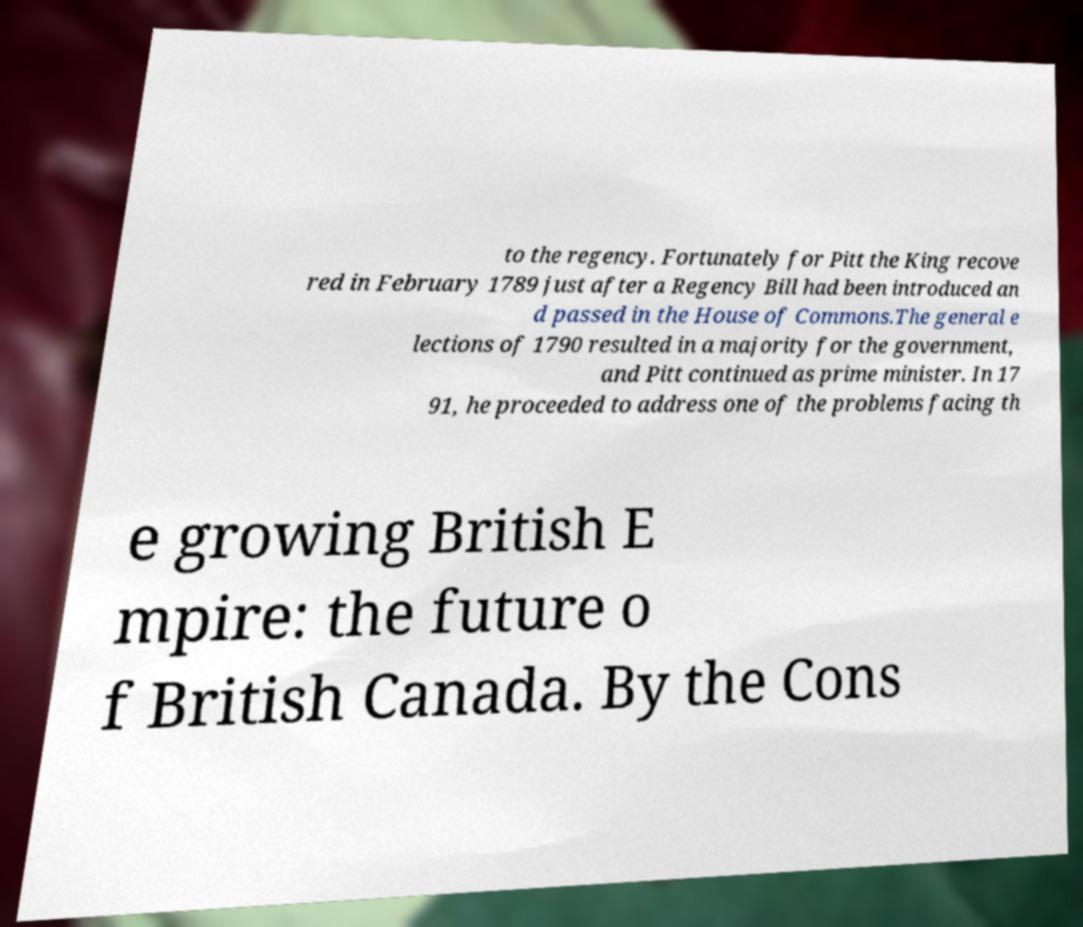For documentation purposes, I need the text within this image transcribed. Could you provide that? to the regency. Fortunately for Pitt the King recove red in February 1789 just after a Regency Bill had been introduced an d passed in the House of Commons.The general e lections of 1790 resulted in a majority for the government, and Pitt continued as prime minister. In 17 91, he proceeded to address one of the problems facing th e growing British E mpire: the future o f British Canada. By the Cons 